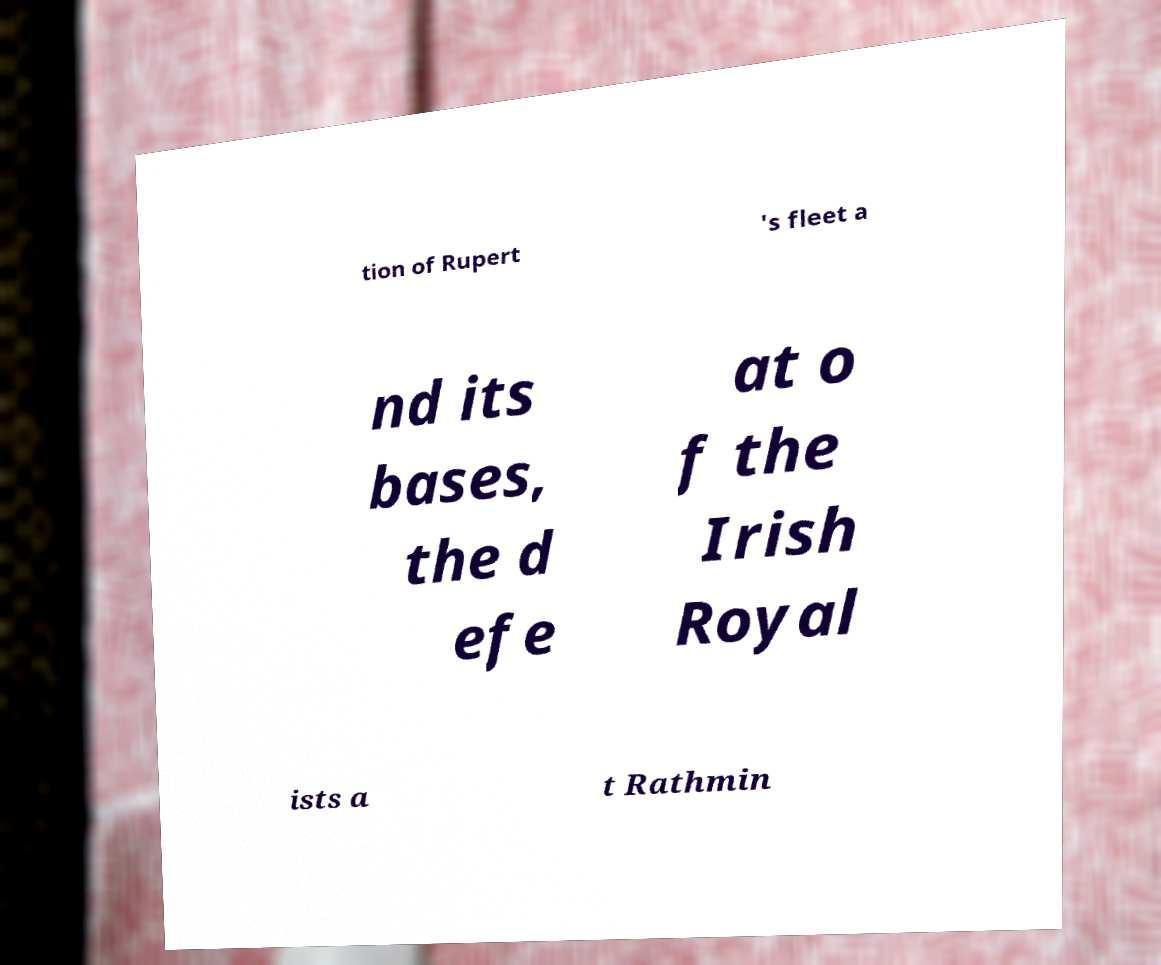Could you extract and type out the text from this image? tion of Rupert 's fleet a nd its bases, the d efe at o f the Irish Royal ists a t Rathmin 